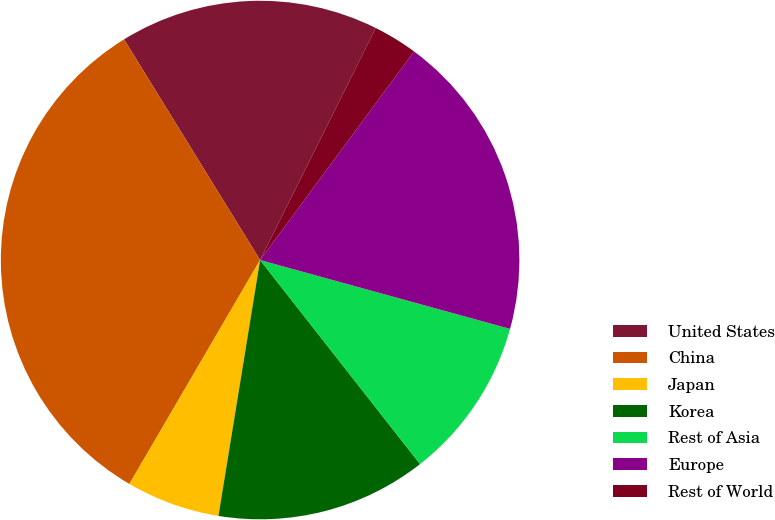Convert chart. <chart><loc_0><loc_0><loc_500><loc_500><pie_chart><fcel>United States<fcel>China<fcel>Japan<fcel>Korea<fcel>Rest of Asia<fcel>Europe<fcel>Rest of World<nl><fcel>16.15%<fcel>32.8%<fcel>5.84%<fcel>13.15%<fcel>10.14%<fcel>19.16%<fcel>2.76%<nl></chart> 